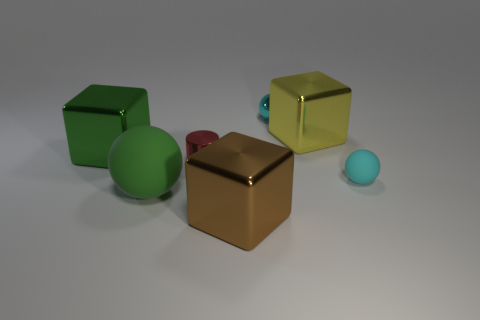Is the cyan ball left of the small rubber ball made of the same material as the cube on the left side of the big matte sphere?
Provide a succinct answer. Yes. What is the material of the cube that is on the left side of the yellow shiny cube and behind the brown block?
Ensure brevity in your answer.  Metal. There is a big green matte object; does it have the same shape as the rubber object to the right of the small red metal cylinder?
Keep it short and to the point. Yes. What is the large object in front of the big green object that is in front of the small cyan thing right of the large yellow metallic thing made of?
Give a very brief answer. Metal. What number of other objects are the same size as the cyan metallic object?
Your answer should be compact. 2. Is the metal cylinder the same color as the small rubber object?
Offer a terse response. No. There is a large metal object in front of the large green thing in front of the cyan rubber thing; what number of spheres are in front of it?
Provide a short and direct response. 0. What is the material of the ball that is to the right of the tiny cyan shiny object to the left of the tiny cyan rubber thing?
Provide a succinct answer. Rubber. Is there a large object that has the same shape as the tiny cyan rubber thing?
Your response must be concise. Yes. There is a sphere that is the same size as the green metallic thing; what is its color?
Your answer should be compact. Green. 